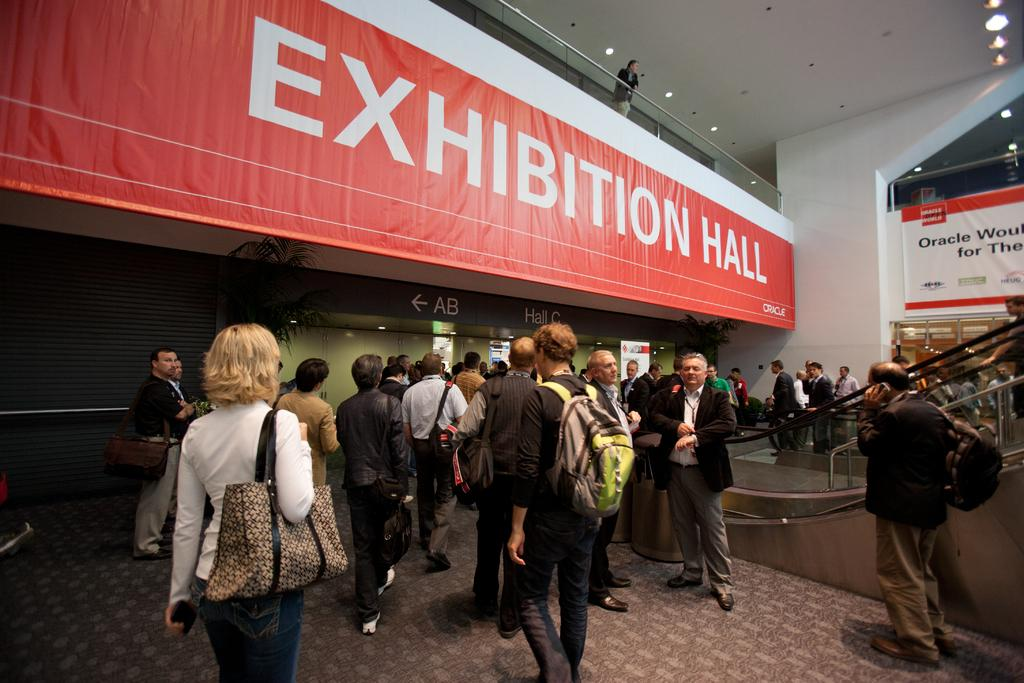What are the people in the image doing? The people in the image are walking. What are the people wearing that is visible in the image? The people are wearing bags. What is located at the top of the image? There is a board at the top of the image. What can be seen on the board? There is text on the board. What can be seen in the image that provides illumination? There are lights visible in the image. Where is the man standing in the image? The man is standing near a glass wall. What type of rifle is the man holding in the image? There is no rifle present in the image; the man is standing near a glass wall without any visible weapons. How many seats are visible in the image? There are no seats visible in the image. 